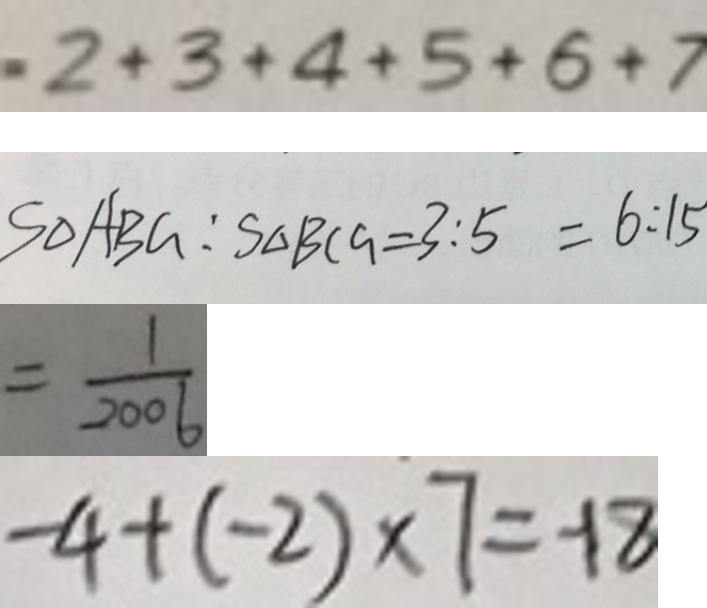Convert formula to latex. <formula><loc_0><loc_0><loc_500><loc_500>2 + 3 + 4 + 5 + 6 + 7 
 S _ { \Delta A B G } : S _ { \Delta B C G } = 3 : 5 = 6 : 1 5 
 = \frac { 1 } { 2 0 0 6 } 
 - 4 + ( - 2 ) \times 7 = - 1 8</formula> 